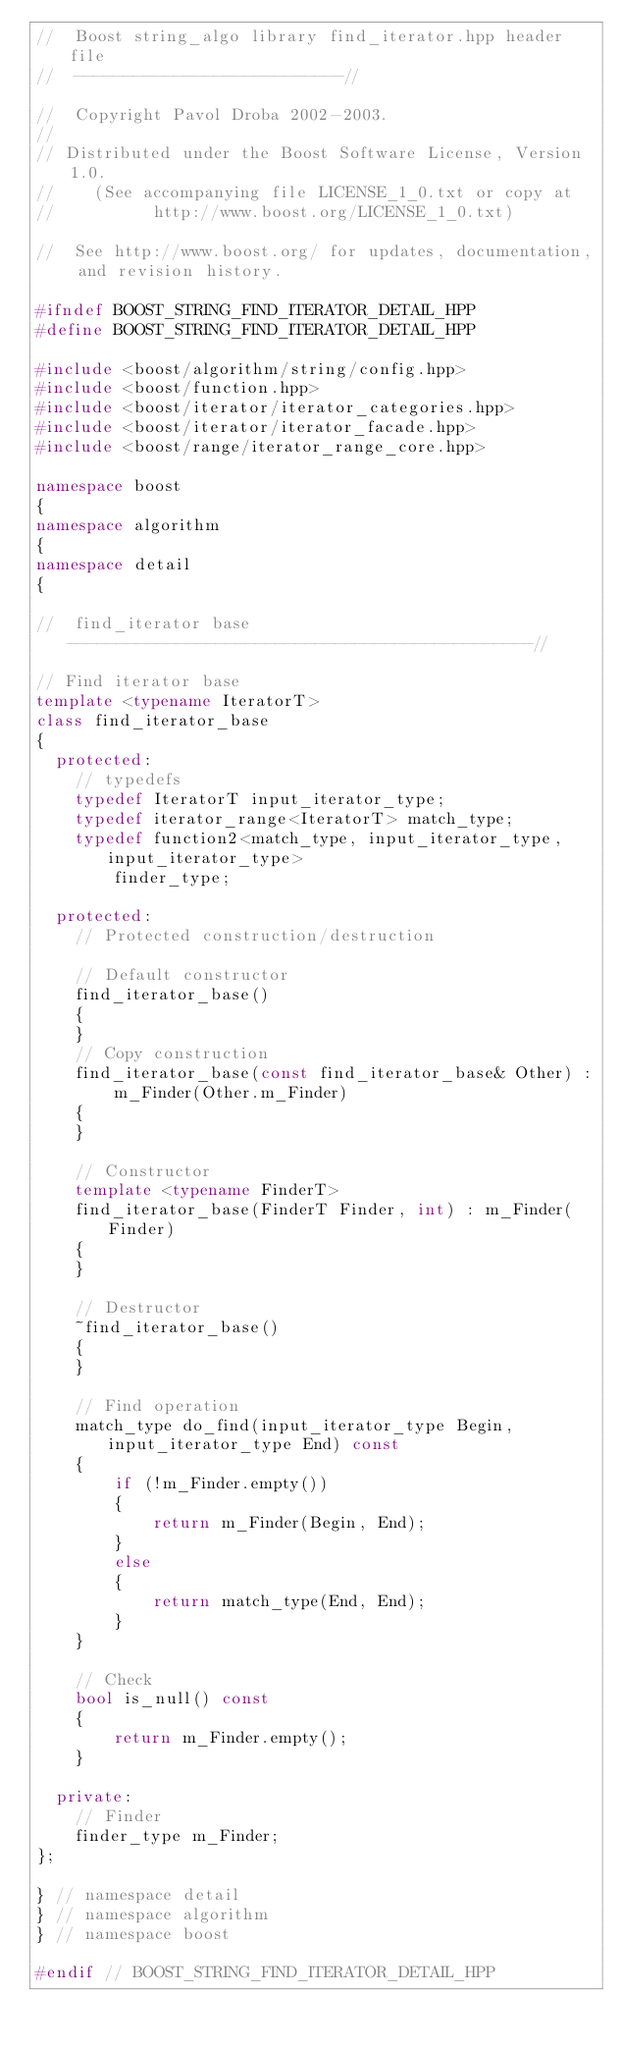<code> <loc_0><loc_0><loc_500><loc_500><_C++_>//  Boost string_algo library find_iterator.hpp header file
//  ---------------------------//

//  Copyright Pavol Droba 2002-2003.
//
// Distributed under the Boost Software License, Version 1.0.
//    (See accompanying file LICENSE_1_0.txt or copy at
//          http://www.boost.org/LICENSE_1_0.txt)

//  See http://www.boost.org/ for updates, documentation, and revision history.

#ifndef BOOST_STRING_FIND_ITERATOR_DETAIL_HPP
#define BOOST_STRING_FIND_ITERATOR_DETAIL_HPP

#include <boost/algorithm/string/config.hpp>
#include <boost/function.hpp>
#include <boost/iterator/iterator_categories.hpp>
#include <boost/iterator/iterator_facade.hpp>
#include <boost/range/iterator_range_core.hpp>

namespace boost
{
namespace algorithm
{
namespace detail
{

//  find_iterator base -----------------------------------------------//

// Find iterator base
template <typename IteratorT>
class find_iterator_base
{
  protected:
    // typedefs
    typedef IteratorT input_iterator_type;
    typedef iterator_range<IteratorT> match_type;
    typedef function2<match_type, input_iterator_type, input_iterator_type>
        finder_type;

  protected:
    // Protected construction/destruction

    // Default constructor
    find_iterator_base()
    {
    }
    // Copy construction
    find_iterator_base(const find_iterator_base& Other) :
        m_Finder(Other.m_Finder)
    {
    }

    // Constructor
    template <typename FinderT>
    find_iterator_base(FinderT Finder, int) : m_Finder(Finder)
    {
    }

    // Destructor
    ~find_iterator_base()
    {
    }

    // Find operation
    match_type do_find(input_iterator_type Begin, input_iterator_type End) const
    {
        if (!m_Finder.empty())
        {
            return m_Finder(Begin, End);
        }
        else
        {
            return match_type(End, End);
        }
    }

    // Check
    bool is_null() const
    {
        return m_Finder.empty();
    }

  private:
    // Finder
    finder_type m_Finder;
};

} // namespace detail
} // namespace algorithm
} // namespace boost

#endif // BOOST_STRING_FIND_ITERATOR_DETAIL_HPP
</code> 